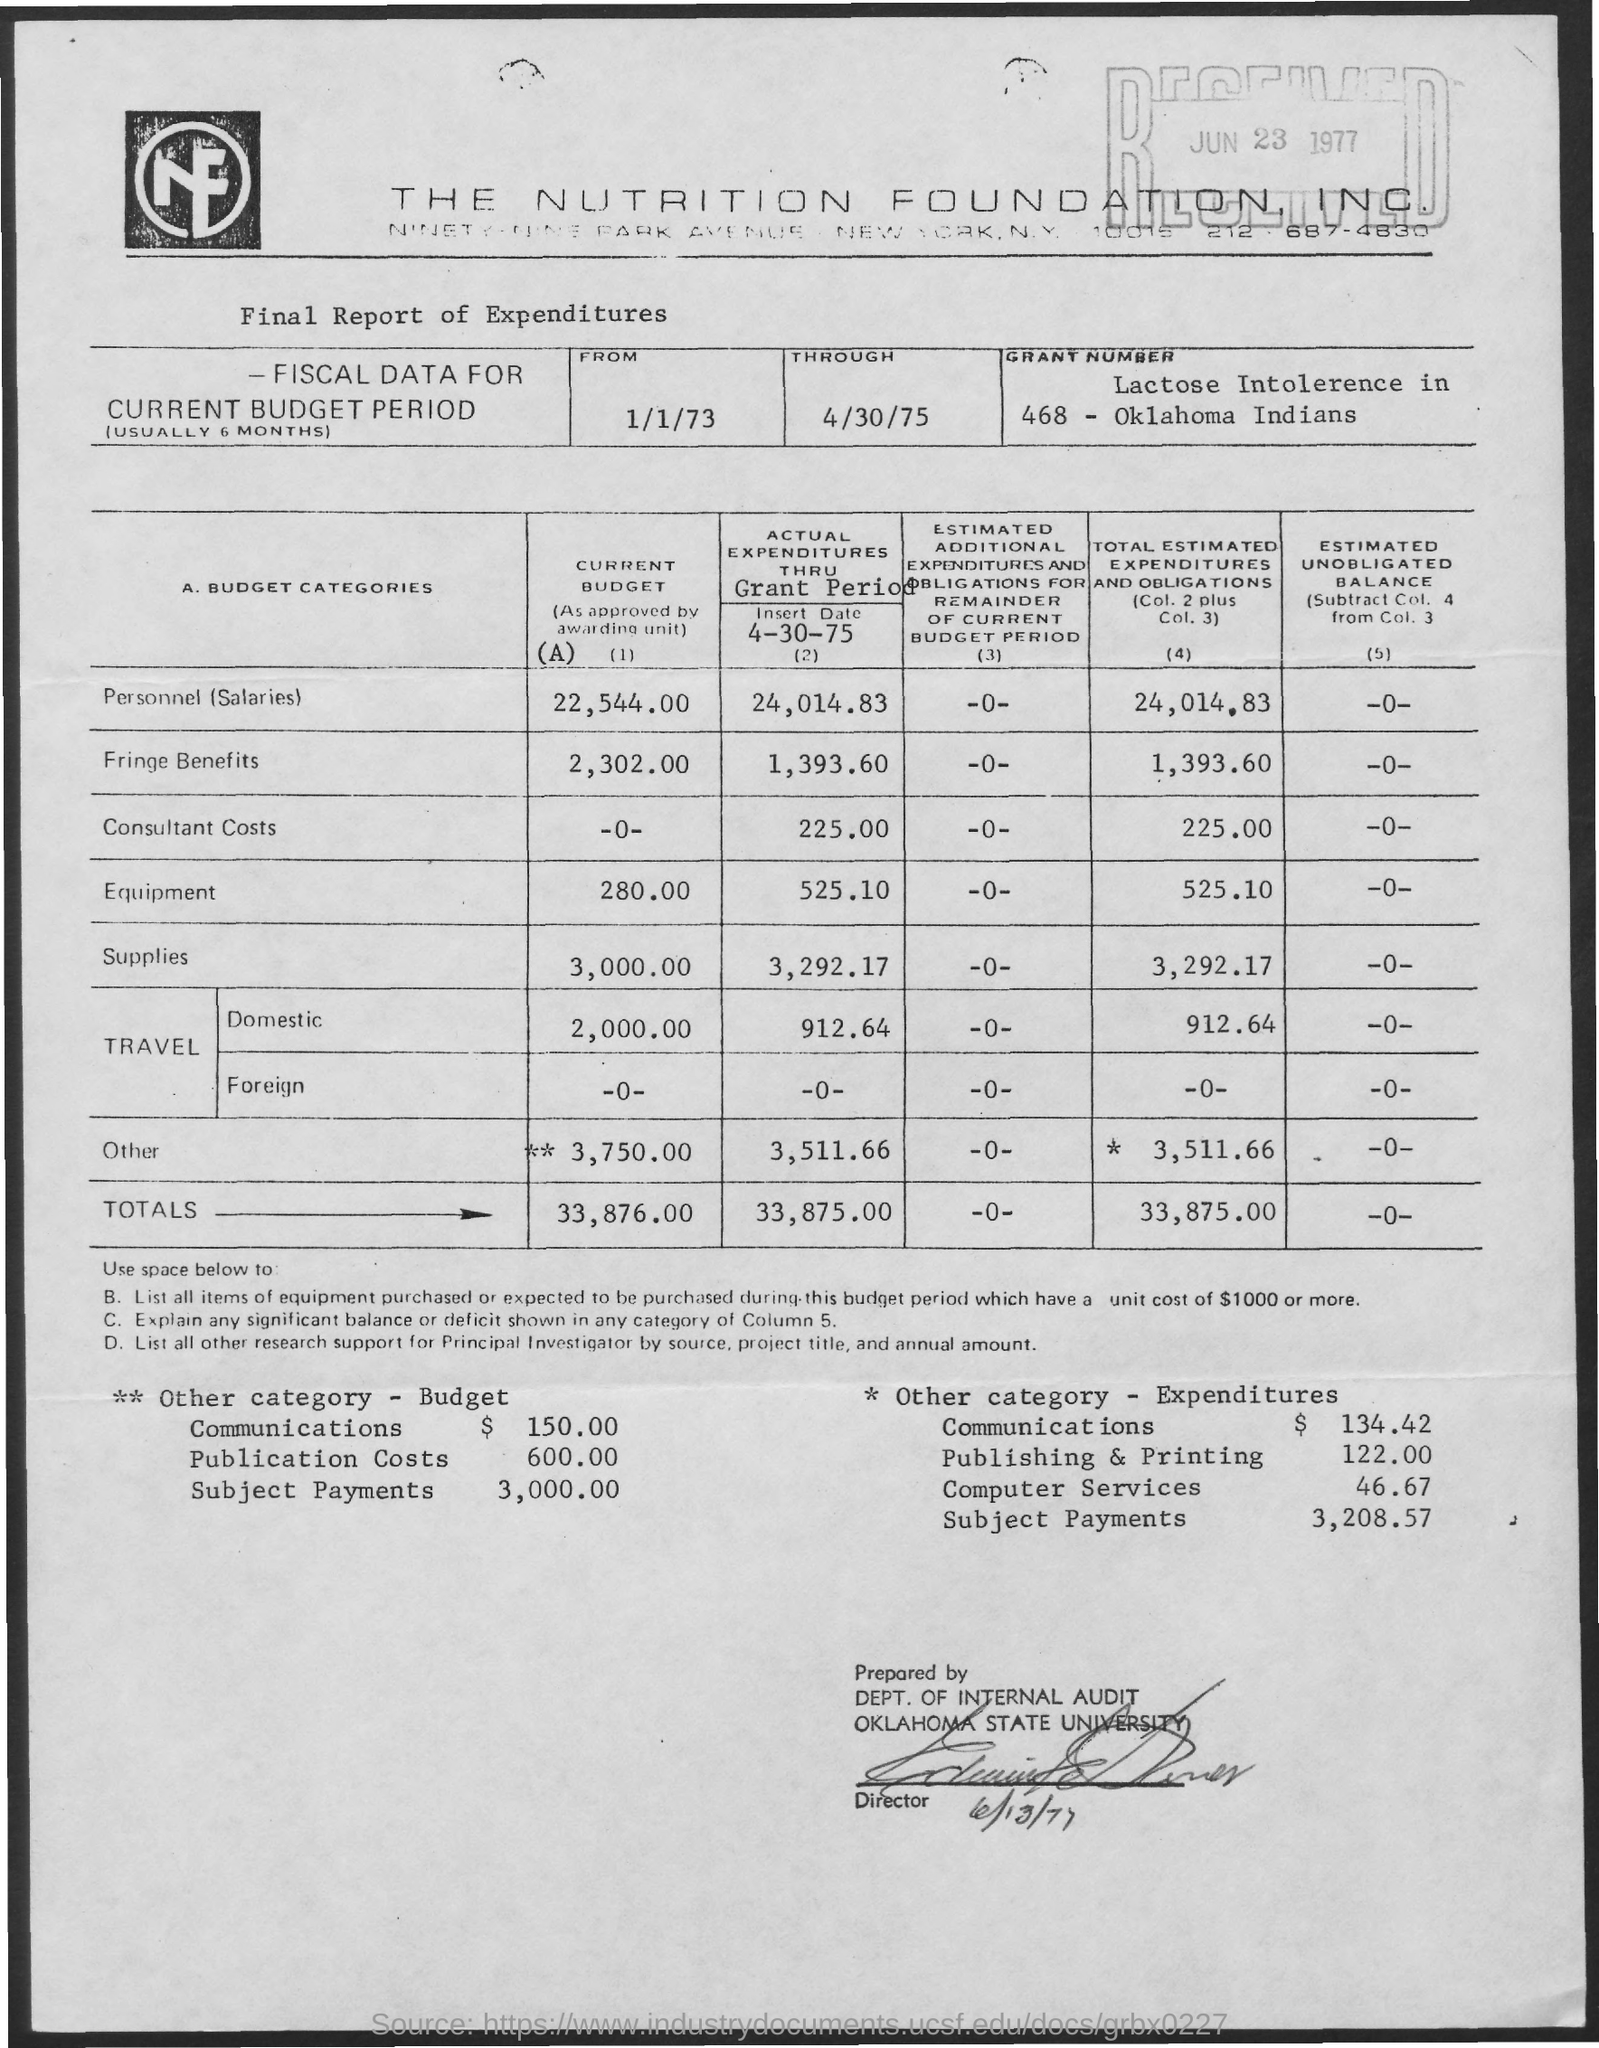Give some essential details in this illustration. The Nutrition Foundation, INC., is the name of the company. The total current budget is 33,876.00. 